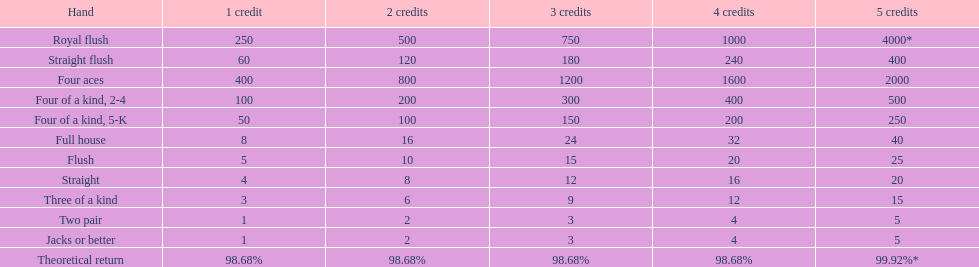Upon securing a full house win with four credits, what amount is paid out? 32. 